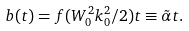<formula> <loc_0><loc_0><loc_500><loc_500>b ( t ) = f ( W _ { 0 } ^ { 2 } k _ { 0 } ^ { 2 } / 2 ) t \equiv \tilde { \alpha } t .</formula> 